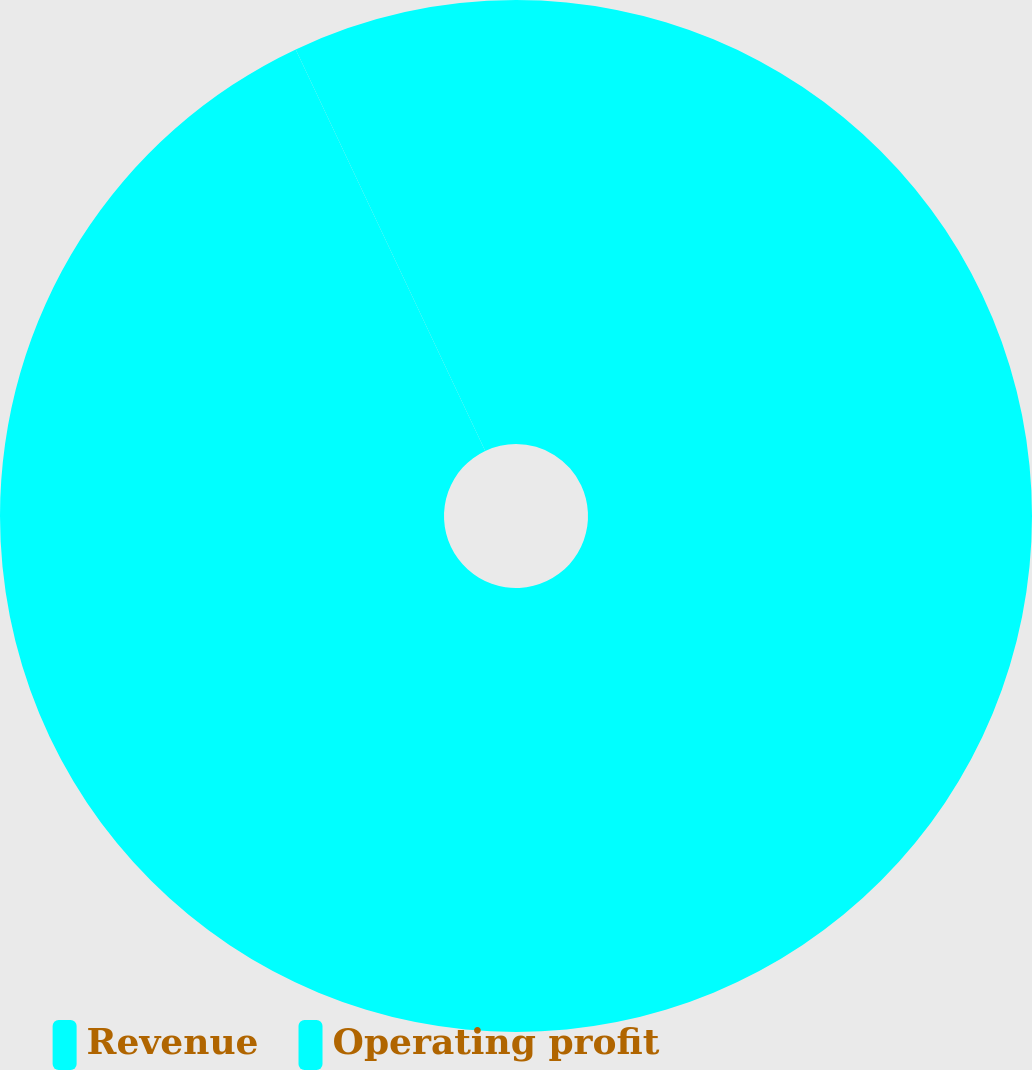Convert chart. <chart><loc_0><loc_0><loc_500><loc_500><pie_chart><fcel>Revenue<fcel>Operating profit<nl><fcel>92.98%<fcel>7.02%<nl></chart> 